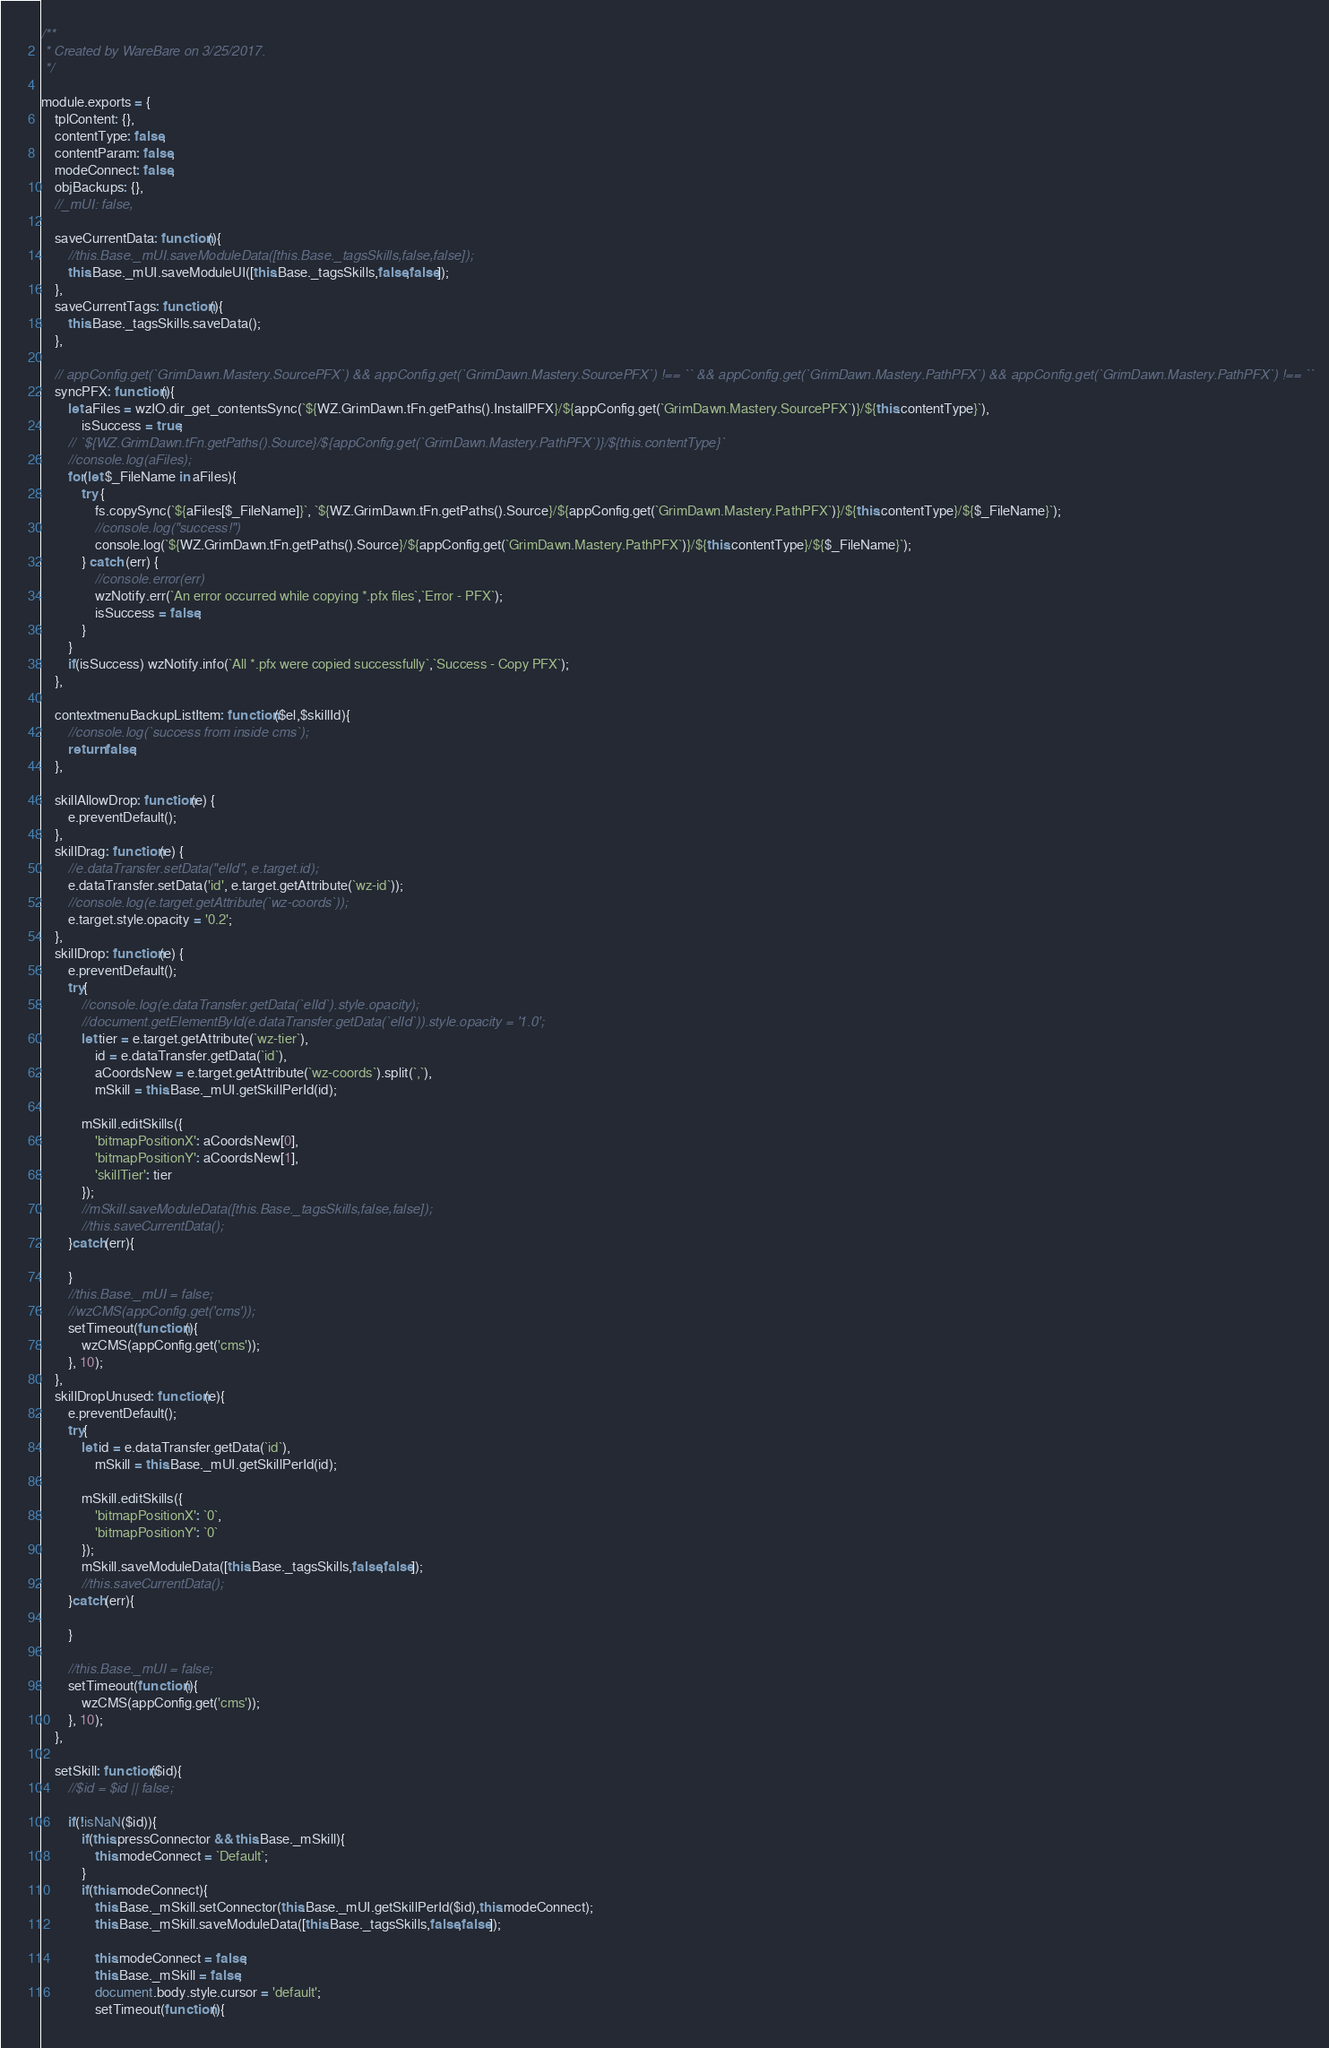Convert code to text. <code><loc_0><loc_0><loc_500><loc_500><_JavaScript_>/**
 * Created by WareBare on 3/25/2017.
 */

module.exports = {
    tplContent: {},
    contentType: false,
    contentParam: false,
    modeConnect: false,
    objBackups: {},
    //_mUI: false,
    
    saveCurrentData: function(){
        //this.Base._mUI.saveModuleData([this.Base._tagsSkills,false,false]);
        this.Base._mUI.saveModuleUI([this.Base._tagsSkills,false,false]);
    },
    saveCurrentTags: function(){
        this.Base._tagsSkills.saveData();
    },
    
    // appConfig.get(`GrimDawn.Mastery.SourcePFX`) && appConfig.get(`GrimDawn.Mastery.SourcePFX`) !== `` && appConfig.get(`GrimDawn.Mastery.PathPFX`) && appConfig.get(`GrimDawn.Mastery.PathPFX`) !== ``
    syncPFX: function(){
        let aFiles = wzIO.dir_get_contentsSync(`${WZ.GrimDawn.tFn.getPaths().InstallPFX}/${appConfig.get(`GrimDawn.Mastery.SourcePFX`)}/${this.contentType}`),
            isSuccess = true;
        // `${WZ.GrimDawn.tFn.getPaths().Source}/${appConfig.get(`GrimDawn.Mastery.PathPFX`)}/${this.contentType}`
        //console.log(aFiles);
        for(let $_FileName in aFiles){
            try {
                fs.copySync(`${aFiles[$_FileName]}`, `${WZ.GrimDawn.tFn.getPaths().Source}/${appConfig.get(`GrimDawn.Mastery.PathPFX`)}/${this.contentType}/${$_FileName}`);
                //console.log("success!")
                console.log(`${WZ.GrimDawn.tFn.getPaths().Source}/${appConfig.get(`GrimDawn.Mastery.PathPFX`)}/${this.contentType}/${$_FileName}`);
            } catch (err) {
                //console.error(err)
                wzNotify.err(`An error occurred while copying *.pfx files`,`Error - PFX`);
                isSuccess = false;
            }
        }
        if(isSuccess) wzNotify.info(`All *.pfx were copied successfully`,`Success - Copy PFX`);
    },
    
    contextmenuBackupListItem: function($el,$skillId){
        //console.log(`success from inside cms`);
        return false;
    },
    
    skillAllowDrop: function(e) {
        e.preventDefault();
    },
    skillDrag: function(e) {
        //e.dataTransfer.setData("elId", e.target.id);
        e.dataTransfer.setData('id', e.target.getAttribute(`wz-id`));
        //console.log(e.target.getAttribute(`wz-coords`));
        e.target.style.opacity = '0.2';
    },
    skillDrop: function(e) {
        e.preventDefault();
        try{
            //console.log(e.dataTransfer.getData(`elId`).style.opacity);
            //document.getElementById(e.dataTransfer.getData(`elId`)).style.opacity = '1.0';
            let tier = e.target.getAttribute(`wz-tier`),
                id = e.dataTransfer.getData(`id`),
                aCoordsNew = e.target.getAttribute(`wz-coords`).split(`,`),
                mSkill = this.Base._mUI.getSkillPerId(id);
    
            mSkill.editSkills({
                'bitmapPositionX': aCoordsNew[0],
                'bitmapPositionY': aCoordsNew[1],
                'skillTier': tier
            });
            //mSkill.saveModuleData([this.Base._tagsSkills,false,false]);
            //this.saveCurrentData();
        }catch(err){
        
        }
        //this.Base._mUI = false;
        //wzCMS(appConfig.get('cms'));
        setTimeout(function(){
            wzCMS(appConfig.get('cms'));
        }, 10);
    },
    skillDropUnused: function(e){
        e.preventDefault();
        try{
            let id = e.dataTransfer.getData(`id`),
                mSkill = this.Base._mUI.getSkillPerId(id);
    
            mSkill.editSkills({
                'bitmapPositionX': `0`,
                'bitmapPositionY': `0`
            });
            mSkill.saveModuleData([this.Base._tagsSkills,false,false]);
            //this.saveCurrentData();
        }catch(err){
        
        }
    
        //this.Base._mUI = false;
        setTimeout(function(){
            wzCMS(appConfig.get('cms'));
        }, 10);
    },
    
    setSkill: function($id){
        //$id = $id || false;
        
        if(!isNaN($id)){
            if(this.pressConnector && this.Base._mSkill){
                this.modeConnect = `Default`;
            }
            if(this.modeConnect){
                this.Base._mSkill.setConnector(this.Base._mUI.getSkillPerId($id),this.modeConnect);
                this.Base._mSkill.saveModuleData([this.Base._tagsSkills,false,false]);
                
                this.modeConnect = false;
                this.Base._mSkill = false;
                document.body.style.cursor = 'default';
                setTimeout(function(){</code> 